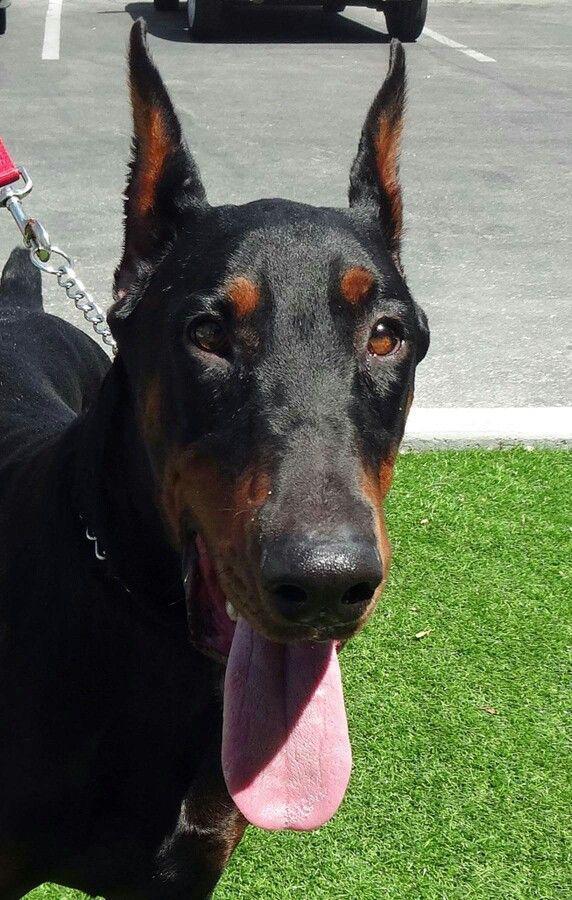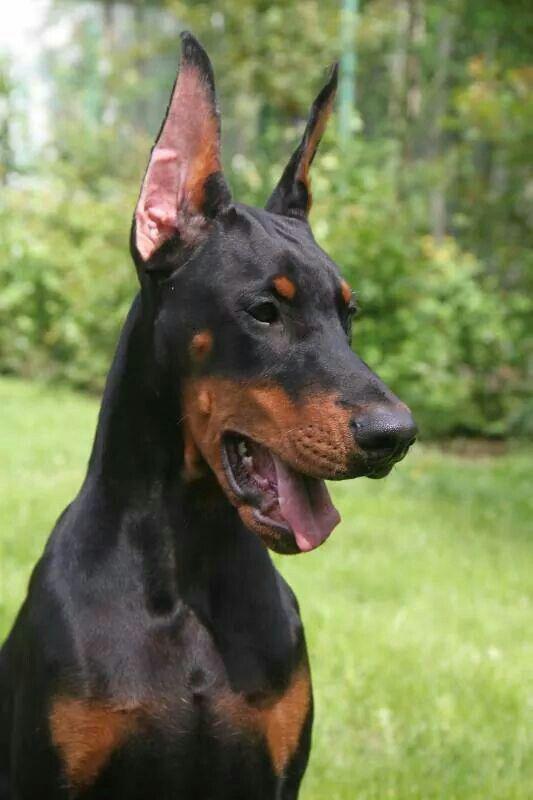The first image is the image on the left, the second image is the image on the right. Examine the images to the left and right. Is the description "Each image contains one dog, and one of the dogs depicted wears a chain collar, while the other dog has something held in its mouth." accurate? Answer yes or no. No. The first image is the image on the left, the second image is the image on the right. Given the left and right images, does the statement "A single dog in the grass is showing its tongue in the image on the left." hold true? Answer yes or no. Yes. 